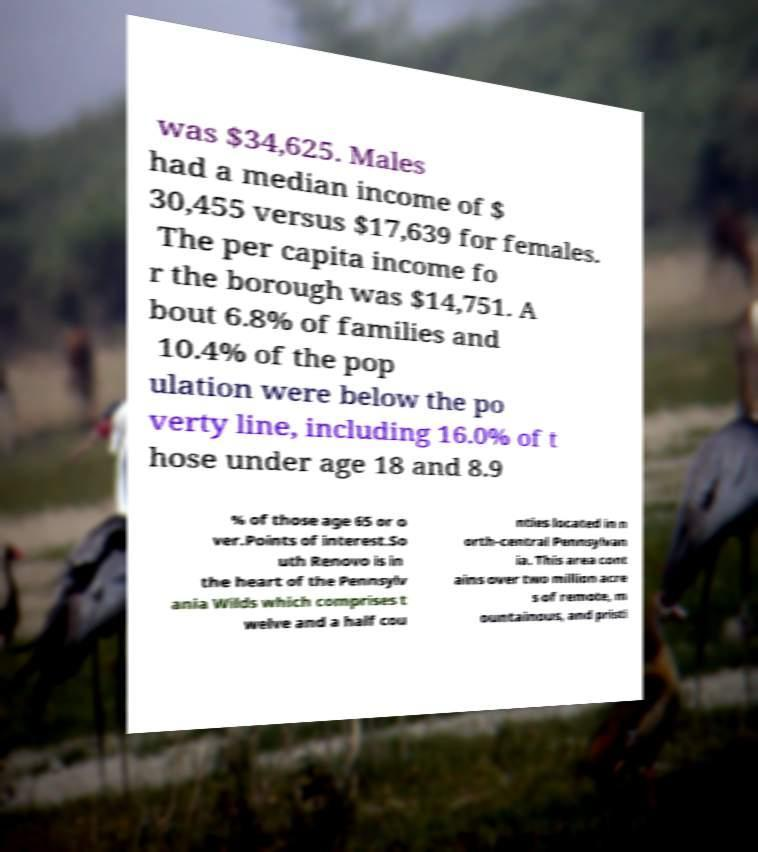There's text embedded in this image that I need extracted. Can you transcribe it verbatim? was $34,625. Males had a median income of $ 30,455 versus $17,639 for females. The per capita income fo r the borough was $14,751. A bout 6.8% of families and 10.4% of the pop ulation were below the po verty line, including 16.0% of t hose under age 18 and 8.9 % of those age 65 or o ver.Points of interest.So uth Renovo is in the heart of the Pennsylv ania Wilds which comprises t welve and a half cou nties located in n orth-central Pennsylvan ia. This area cont ains over two million acre s of remote, m ountainous, and pristi 